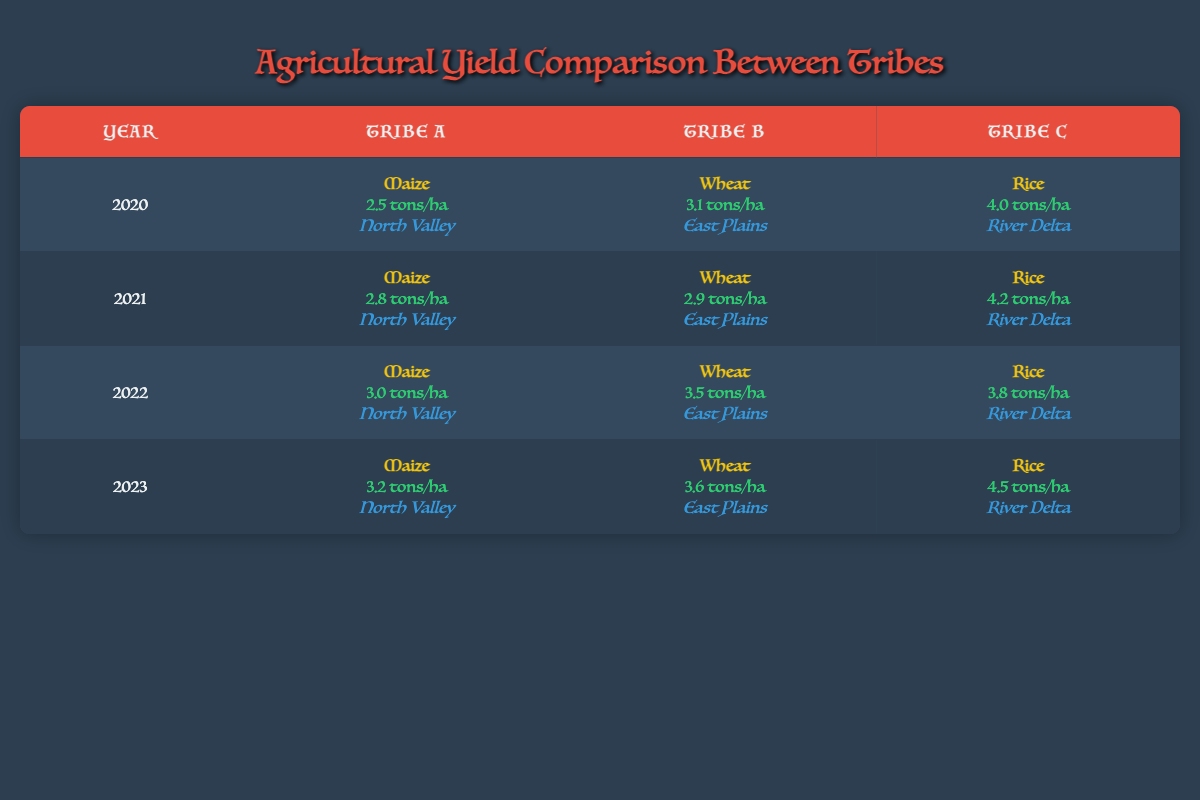What was the yield of Tribe C in 2022? To find the yield for Tribe C in 2022, I look at the row for 2022 and find the corresponding entry for Tribe C. It shows a yield of 3.8 tons/ha.
Answer: 3.8 tons/ha Which tribe consistently had the highest yield in 2020? In 2020, I compare the yields of all three tribes: Tribe A had 2.5 tons/ha, Tribe B had 3.1 tons/ha, and Tribe C had 4.0 tons/ha. Tribe C had the highest yield.
Answer: Tribe C What is the average yield for Tribe A over the four years? To calculate the average yield for Tribe A, I sum the yields for the years 2020 (2.5), 2021 (2.8), 2022 (3.0), and 2023 (3.2), which equals 11.5 tons/ha. Then I divide this sum by 4 (the number of years): 11.5 / 4 = 2.875.
Answer: 2.875 tons/ha Did Tribe B have a higher yield than Tribe A in 2023? In 2023, Tribe A's yield was 3.2 tons/ha, while Tribe B's yield was 3.6 tons/ha. Since 3.6 is greater than 3.2, Tribe B indeed had a higher yield.
Answer: Yes What was the difference in yield between Tribe C and Tribe B in 2021? For 2021, Tribe C had a yield of 4.2 tons/ha and Tribe B had a yield of 2.9 tons/ha. To find the difference, I subtract Tribe B's yield from Tribe C's yield: 4.2 - 2.9 = 1.3 tons/ha.
Answer: 1.3 tons/ha Which tribe's crop was the most productive on average in terms of yield? To determine which tribe had the most productive crop on average, I calculate the average yields: Tribe A: (2.5 + 2.8 + 3.0 + 3.2) / 4 = 2.875, Tribe B: (3.1 + 2.9 + 3.5 + 3.6) / 4 = 3.275, and Tribe C: (4.0 + 4.2 + 3.8 + 4.5) / 4 = 4.125. Tribe C has the highest average yield.
Answer: Tribe C In which year did Tribe A show the greatest increase in yield compared to the previous year? I look at the yields for Tribe A across the years: 2020 (2.5), 2021 (2.8), 2022 (3.0), and 2023 (3.2). The increases are: 2020 to 2021 (+0.3), 2021 to 2022 (+0.2), and 2022 to 2023 (+0.2). The greatest increase was from 2020 to 2021.
Answer: 2021 Is it true that Tribe B's yield decreased from 2020 to 2021? In 2020, Tribe B had a yield of 3.1 tons/ha, which was higher than their yield of 2.9 tons/ha in 2021. Since the yield decreased from one year to the next, the statement is true.
Answer: Yes 